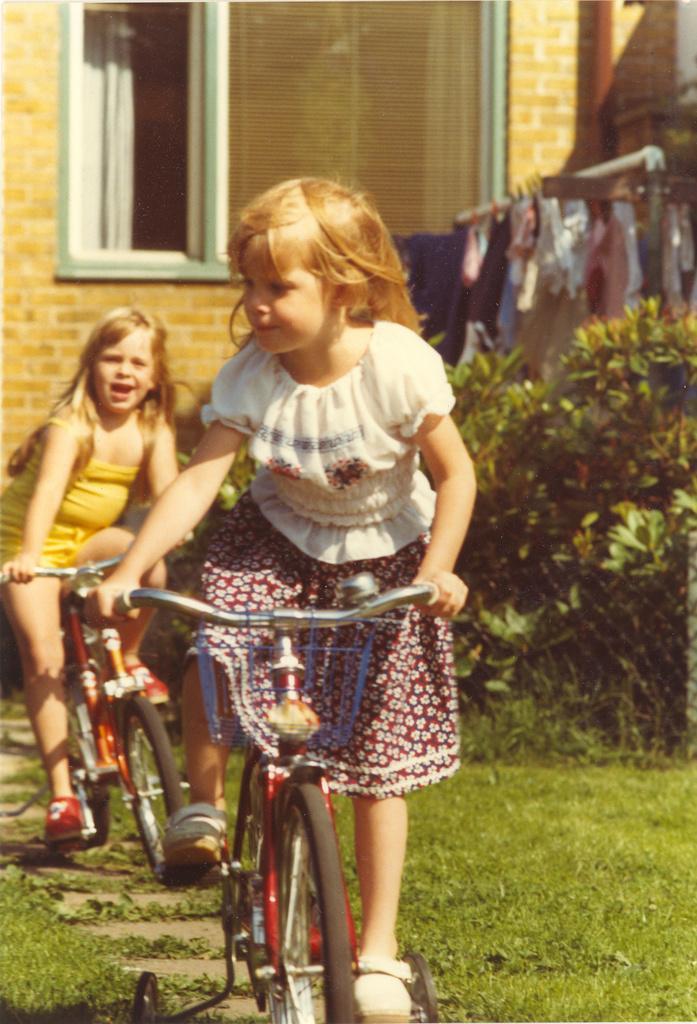How would you summarize this image in a sentence or two? In this image I see 2 girls who are on cycles and I see the grass over. In the background I see the plants, wall, window and the clothes. 